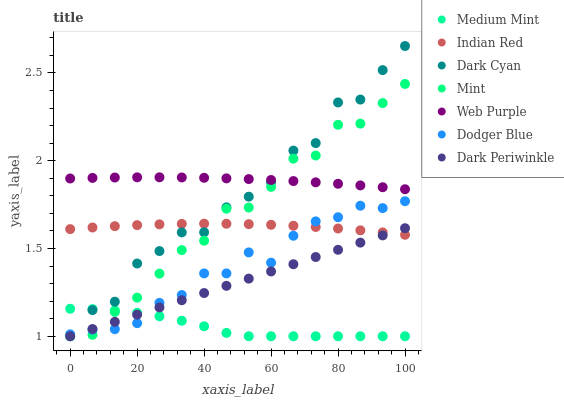Does Medium Mint have the minimum area under the curve?
Answer yes or no. Yes. Does Web Purple have the maximum area under the curve?
Answer yes or no. Yes. Does Dodger Blue have the minimum area under the curve?
Answer yes or no. No. Does Dodger Blue have the maximum area under the curve?
Answer yes or no. No. Is Dark Periwinkle the smoothest?
Answer yes or no. Yes. Is Dark Cyan the roughest?
Answer yes or no. Yes. Is Web Purple the smoothest?
Answer yes or no. No. Is Web Purple the roughest?
Answer yes or no. No. Does Medium Mint have the lowest value?
Answer yes or no. Yes. Does Dodger Blue have the lowest value?
Answer yes or no. No. Does Dark Cyan have the highest value?
Answer yes or no. Yes. Does Web Purple have the highest value?
Answer yes or no. No. Is Dodger Blue less than Web Purple?
Answer yes or no. Yes. Is Web Purple greater than Medium Mint?
Answer yes or no. Yes. Does Dodger Blue intersect Mint?
Answer yes or no. Yes. Is Dodger Blue less than Mint?
Answer yes or no. No. Is Dodger Blue greater than Mint?
Answer yes or no. No. Does Dodger Blue intersect Web Purple?
Answer yes or no. No. 